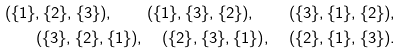Convert formula to latex. <formula><loc_0><loc_0><loc_500><loc_500>( \{ 1 \} , \{ 2 \} , \{ 3 \} ) , \quad ( \{ 1 \} , \{ 3 \} , \{ 2 \} ) , \quad ( \{ 3 \} , \{ 1 \} , \{ 2 \} ) , \\ ( \{ 3 \} , \{ 2 \} , \{ 1 \} ) , \quad ( \{ 2 \} , \{ 3 \} , \{ 1 \} ) , \quad ( \{ 2 \} , \{ 1 \} , \{ 3 \} ) .</formula> 